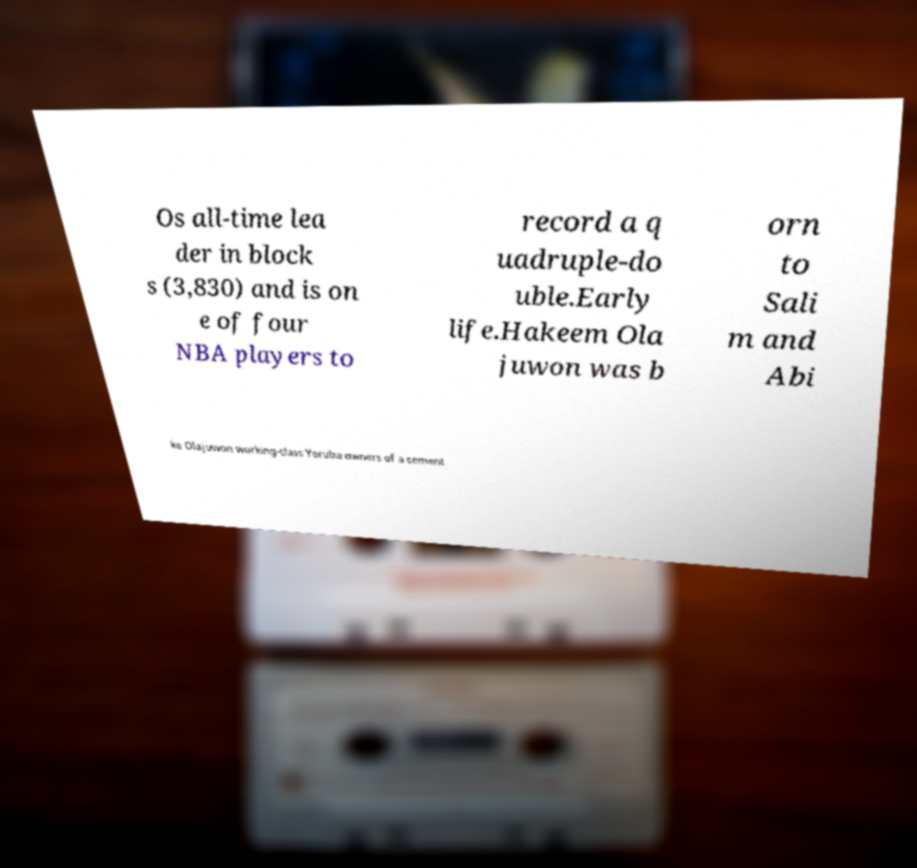Can you accurately transcribe the text from the provided image for me? Os all-time lea der in block s (3,830) and is on e of four NBA players to record a q uadruple-do uble.Early life.Hakeem Ola juwon was b orn to Sali m and Abi ke Olajuwon working-class Yoruba owners of a cement 